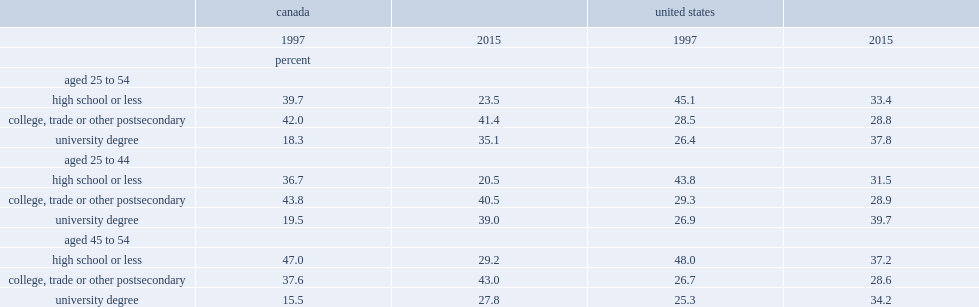How many times of the proportion of women aged 25 to 54 with a university degree has increased in canada from 1997 to 2015? 1.918033. In the united states, what are the proportion of women aged 25 to 54 with a university degree in 1997 and in 2015 respectively? 26.4 37.8. How many times of the proportion of canadian women aged 25 to 44 with a university degree have increased from 1997 to 2015? 2. Which country has women aged 25 to 54 who were more likely to have a university degree in 1997? the united states or canada? United states. 